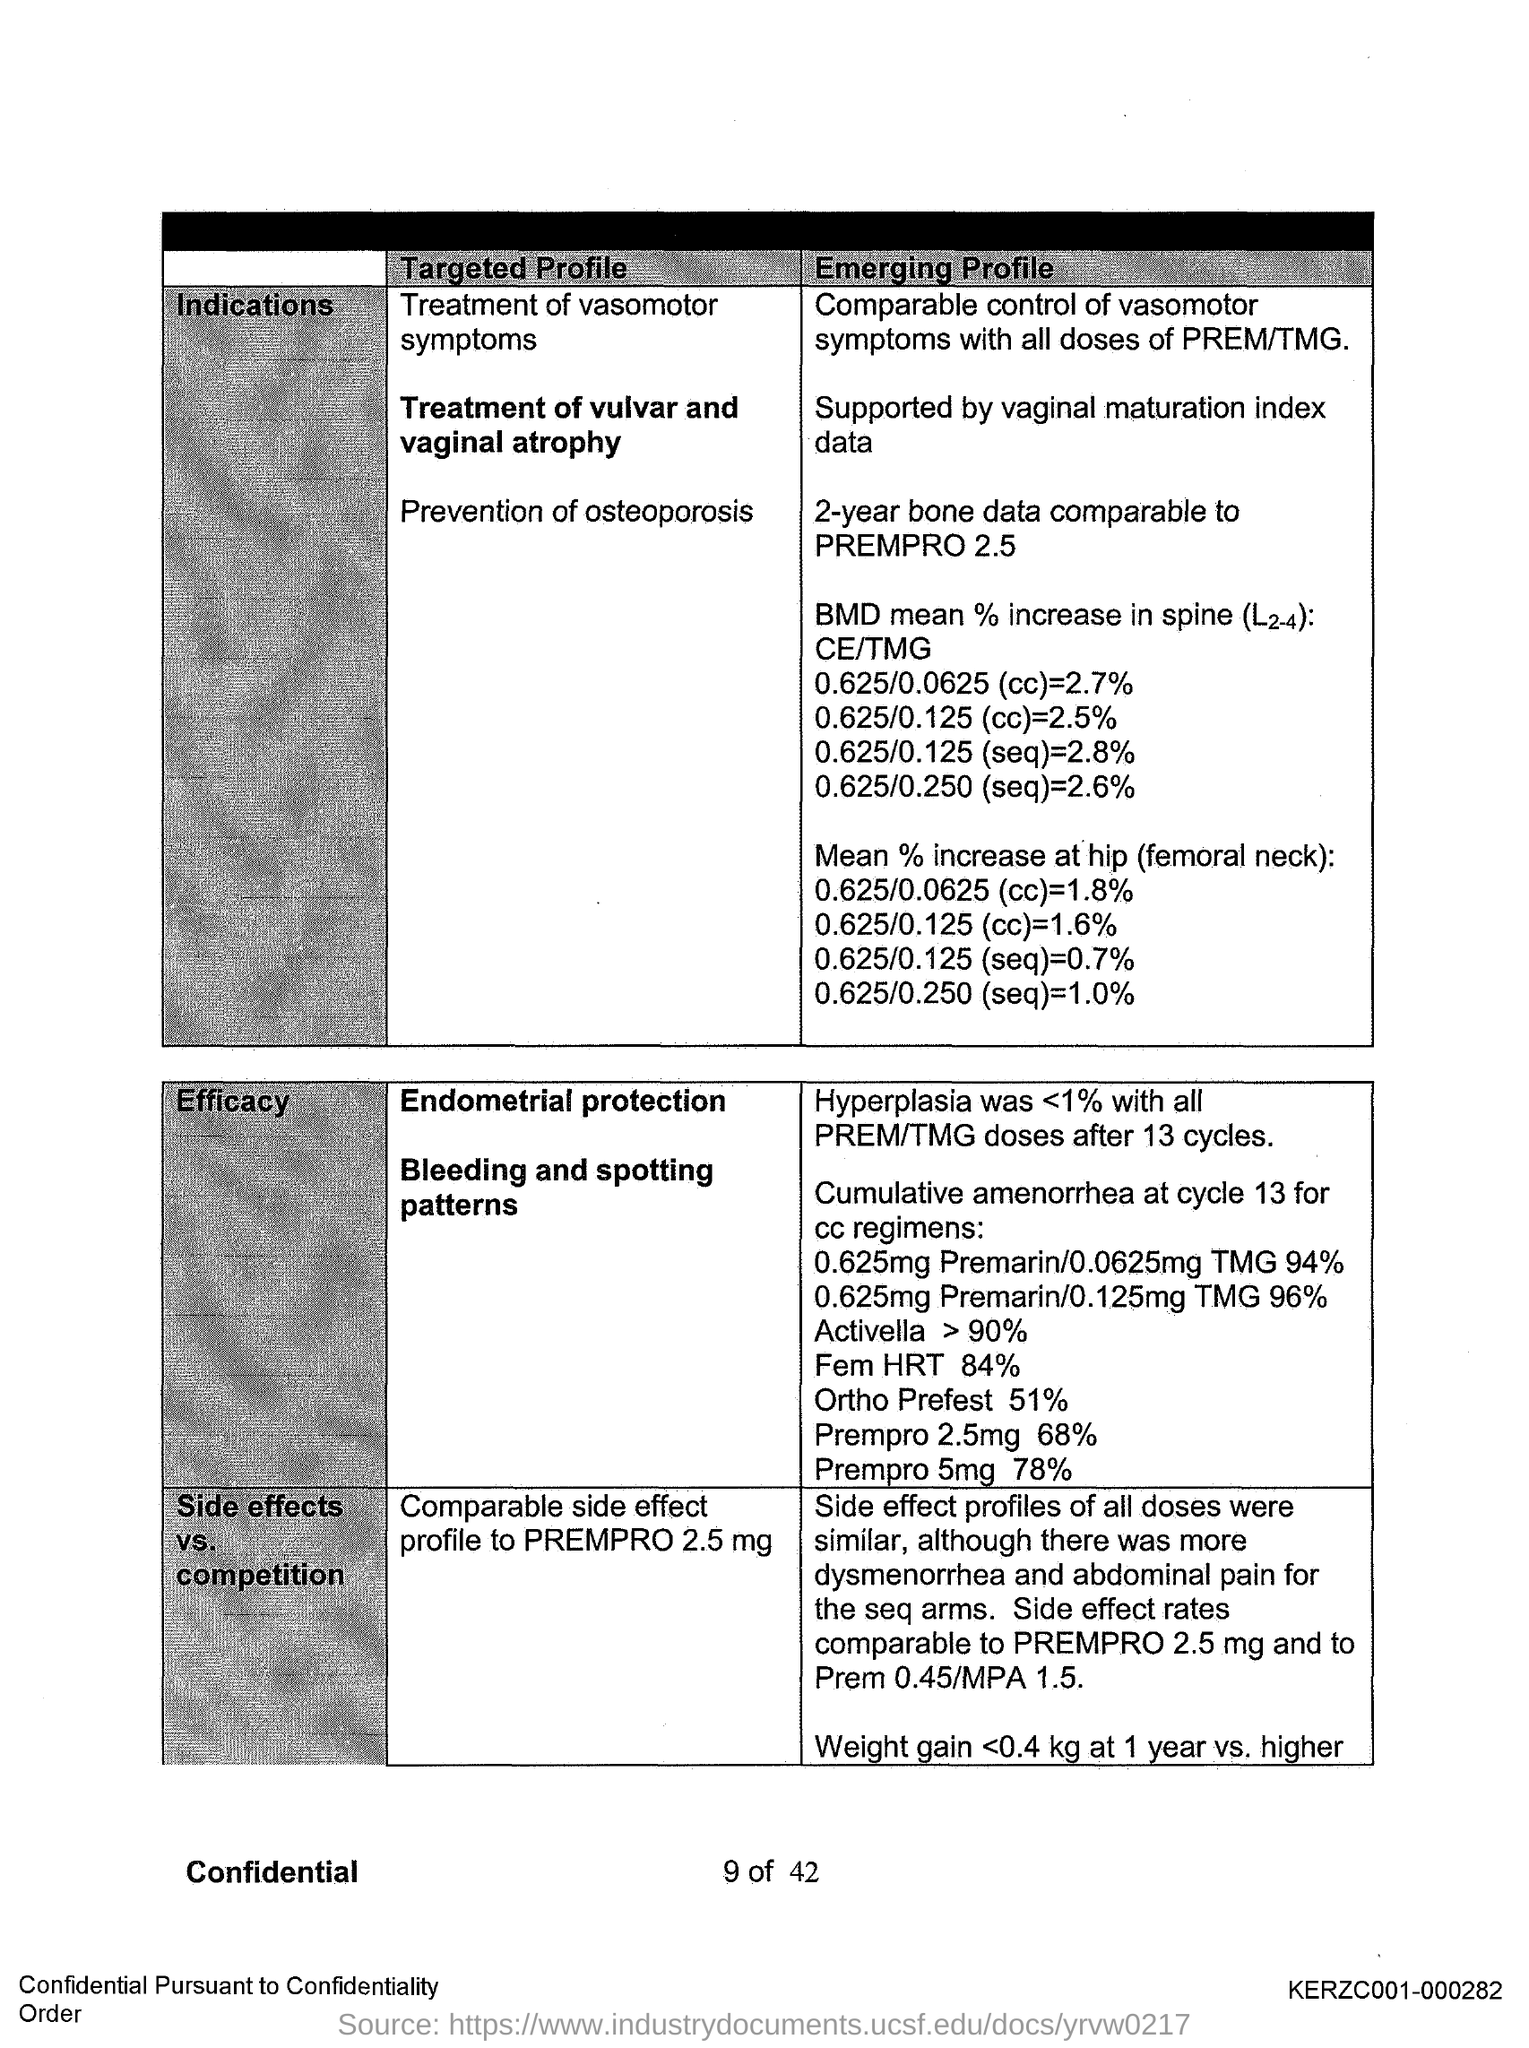What can you infer about the 'Prevention of osteoporosis' section in this image? The section on 'Prevention of osteoporosis' suggests that the document is discussing bone mineral density (BMD) outcomes over two years, comparing them to a known treatment called PREMPRO 2.5. This indicates an interest in showing how effective the treatment is for preventing bone density loss associated with osteoporosis. 